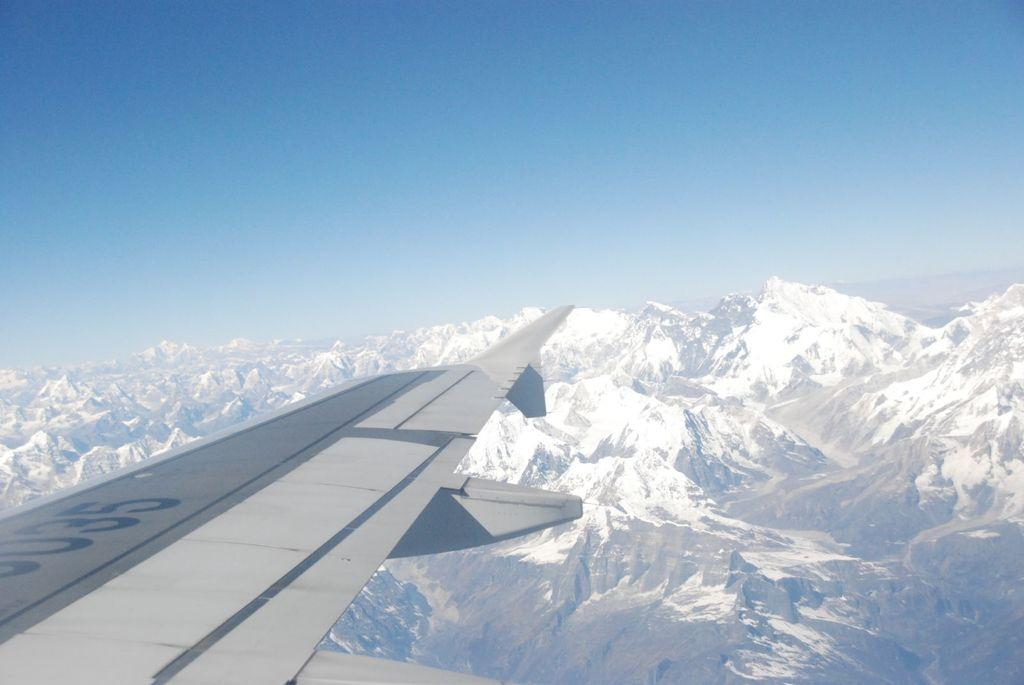What is the main subject of the image? The main subject of the image is a plane. What type of landscape can be seen in the image? There are hills in the image. What part of the natural environment is visible in the image? The sky is visible in the image. What type of quince dish is being served on the plane in the image? There is no quince dish or any food visible in the image; it only features a plane and hills. How many ducks are swimming in the hills in the image? There are no ducks or any animals visible in the hills in the image; it only features hills and a plane. 